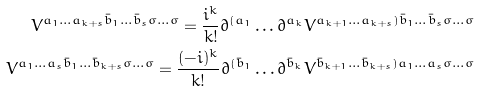<formula> <loc_0><loc_0><loc_500><loc_500>V ^ { a _ { 1 } \dots a _ { k + s } \bar { b } _ { 1 } \dots \bar { b } _ { s } \sigma \dots \sigma } = \frac { i ^ { k } } { k ! } \partial ^ { ( a _ { 1 } } \dots \partial ^ { a _ { k } } V ^ { a _ { k + 1 } \dots a _ { k + s } ) \bar { b } _ { 1 } \dots \bar { b } _ { s } \sigma \dots \sigma } \\ V ^ { a _ { 1 } \dots a _ { s } \bar { b } _ { 1 } \dots \bar { b } _ { k + s } \sigma \dots \sigma } = \frac { ( - i ) ^ { k } } { k ! } \partial ^ { ( \bar { b } _ { 1 } } \dots \partial ^ { \bar { b } _ { k } } V ^ { \bar { b } _ { k + 1 } \dots \bar { b } _ { k + s } ) a _ { 1 } \dots a _ { s } \sigma \dots \sigma }</formula> 